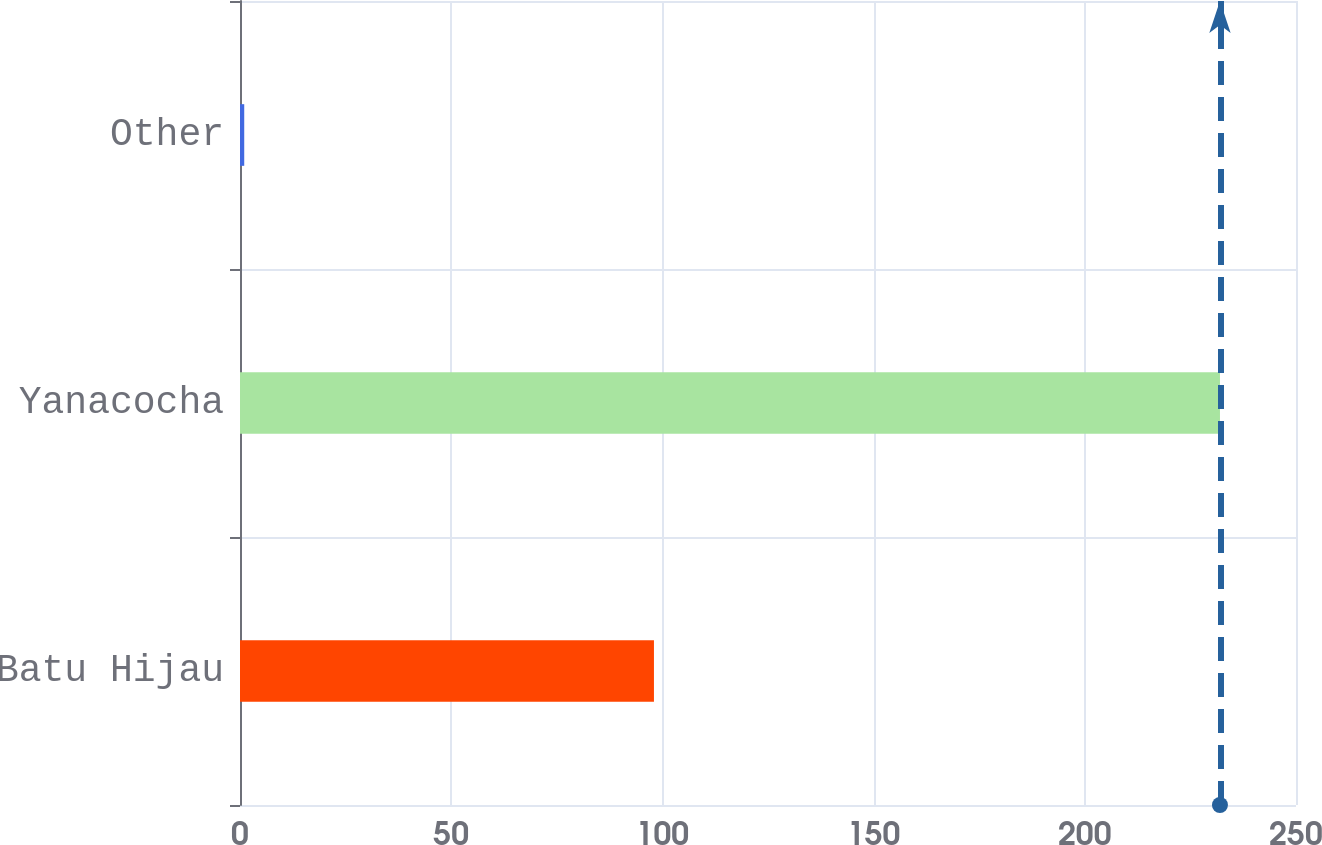Convert chart to OTSL. <chart><loc_0><loc_0><loc_500><loc_500><bar_chart><fcel>Batu Hijau<fcel>Yanacocha<fcel>Other<nl><fcel>98<fcel>232<fcel>1<nl></chart> 